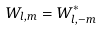Convert formula to latex. <formula><loc_0><loc_0><loc_500><loc_500>W _ { l , m } = W _ { l , - m } ^ { * }</formula> 